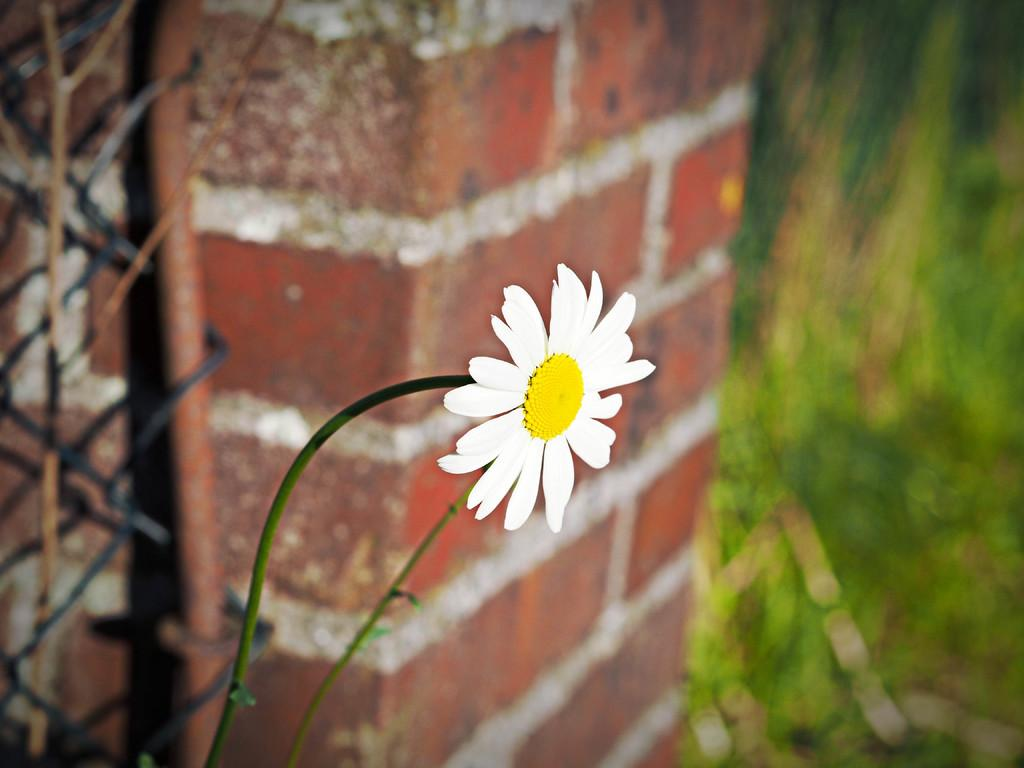What type of plant is in the image? There is a colorful flower in the image. What is the main structure visible in the image? There is a wall in the image. What colors can be seen in the background of the image? The background of the image has blue and green colors. What type of advice can be seen written on the tub in the image? There is no tub present in the image, so no advice can be seen written on it. 